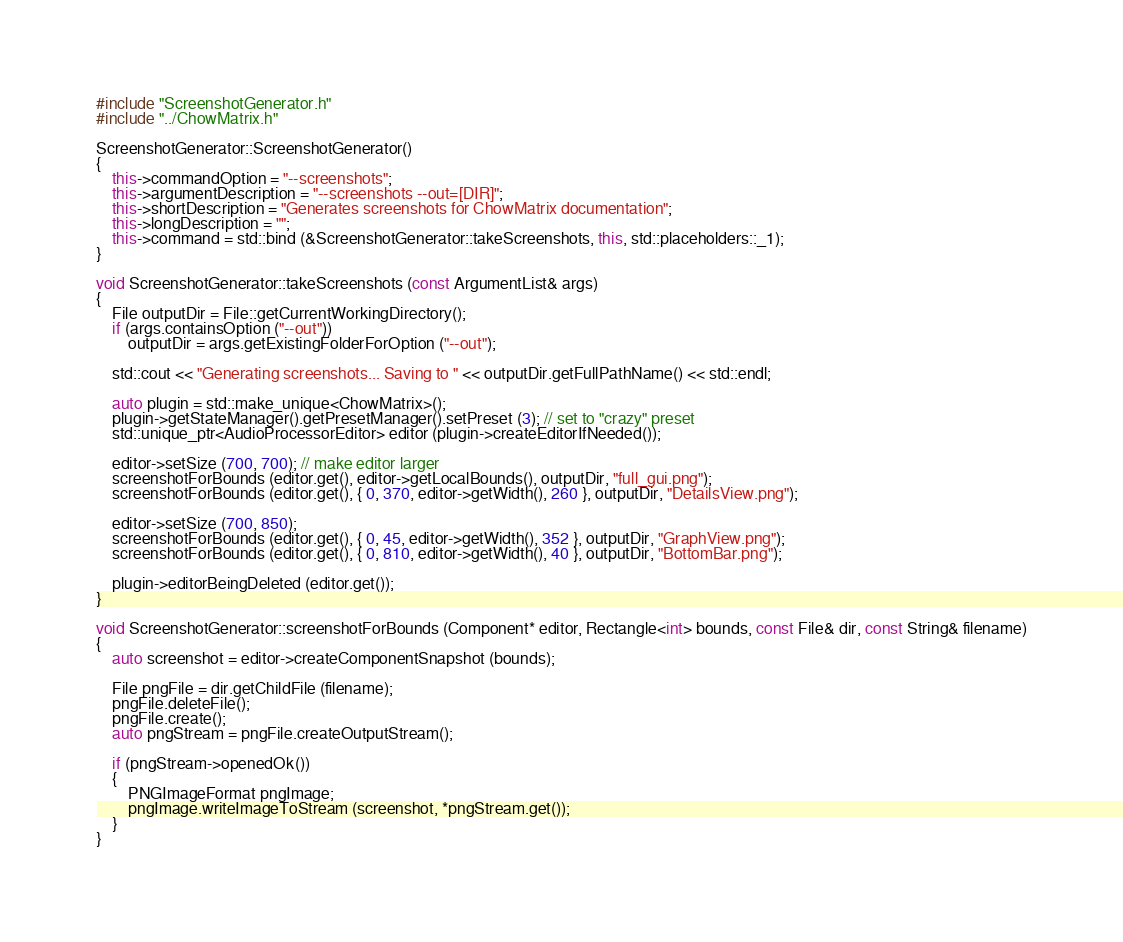Convert code to text. <code><loc_0><loc_0><loc_500><loc_500><_C++_>#include "ScreenshotGenerator.h"
#include "../ChowMatrix.h"

ScreenshotGenerator::ScreenshotGenerator()
{
    this->commandOption = "--screenshots";
    this->argumentDescription = "--screenshots --out=[DIR]";
    this->shortDescription = "Generates screenshots for ChowMatrix documentation";
    this->longDescription = "";
    this->command = std::bind (&ScreenshotGenerator::takeScreenshots, this, std::placeholders::_1);
}

void ScreenshotGenerator::takeScreenshots (const ArgumentList& args)
{
    File outputDir = File::getCurrentWorkingDirectory();
    if (args.containsOption ("--out"))
        outputDir = args.getExistingFolderForOption ("--out");

    std::cout << "Generating screenshots... Saving to " << outputDir.getFullPathName() << std::endl;

    auto plugin = std::make_unique<ChowMatrix>();
    plugin->getStateManager().getPresetManager().setPreset (3); // set to "crazy" preset
    std::unique_ptr<AudioProcessorEditor> editor (plugin->createEditorIfNeeded());

    editor->setSize (700, 700); // make editor larger
    screenshotForBounds (editor.get(), editor->getLocalBounds(), outputDir, "full_gui.png");
    screenshotForBounds (editor.get(), { 0, 370, editor->getWidth(), 260 }, outputDir, "DetailsView.png");

    editor->setSize (700, 850);
    screenshotForBounds (editor.get(), { 0, 45, editor->getWidth(), 352 }, outputDir, "GraphView.png");
    screenshotForBounds (editor.get(), { 0, 810, editor->getWidth(), 40 }, outputDir, "BottomBar.png");

    plugin->editorBeingDeleted (editor.get());
}

void ScreenshotGenerator::screenshotForBounds (Component* editor, Rectangle<int> bounds, const File& dir, const String& filename)
{
    auto screenshot = editor->createComponentSnapshot (bounds);

    File pngFile = dir.getChildFile (filename);
    pngFile.deleteFile();
    pngFile.create();
    auto pngStream = pngFile.createOutputStream();

    if (pngStream->openedOk())
    {
        PNGImageFormat pngImage;
        pngImage.writeImageToStream (screenshot, *pngStream.get());
    }
}
</code> 